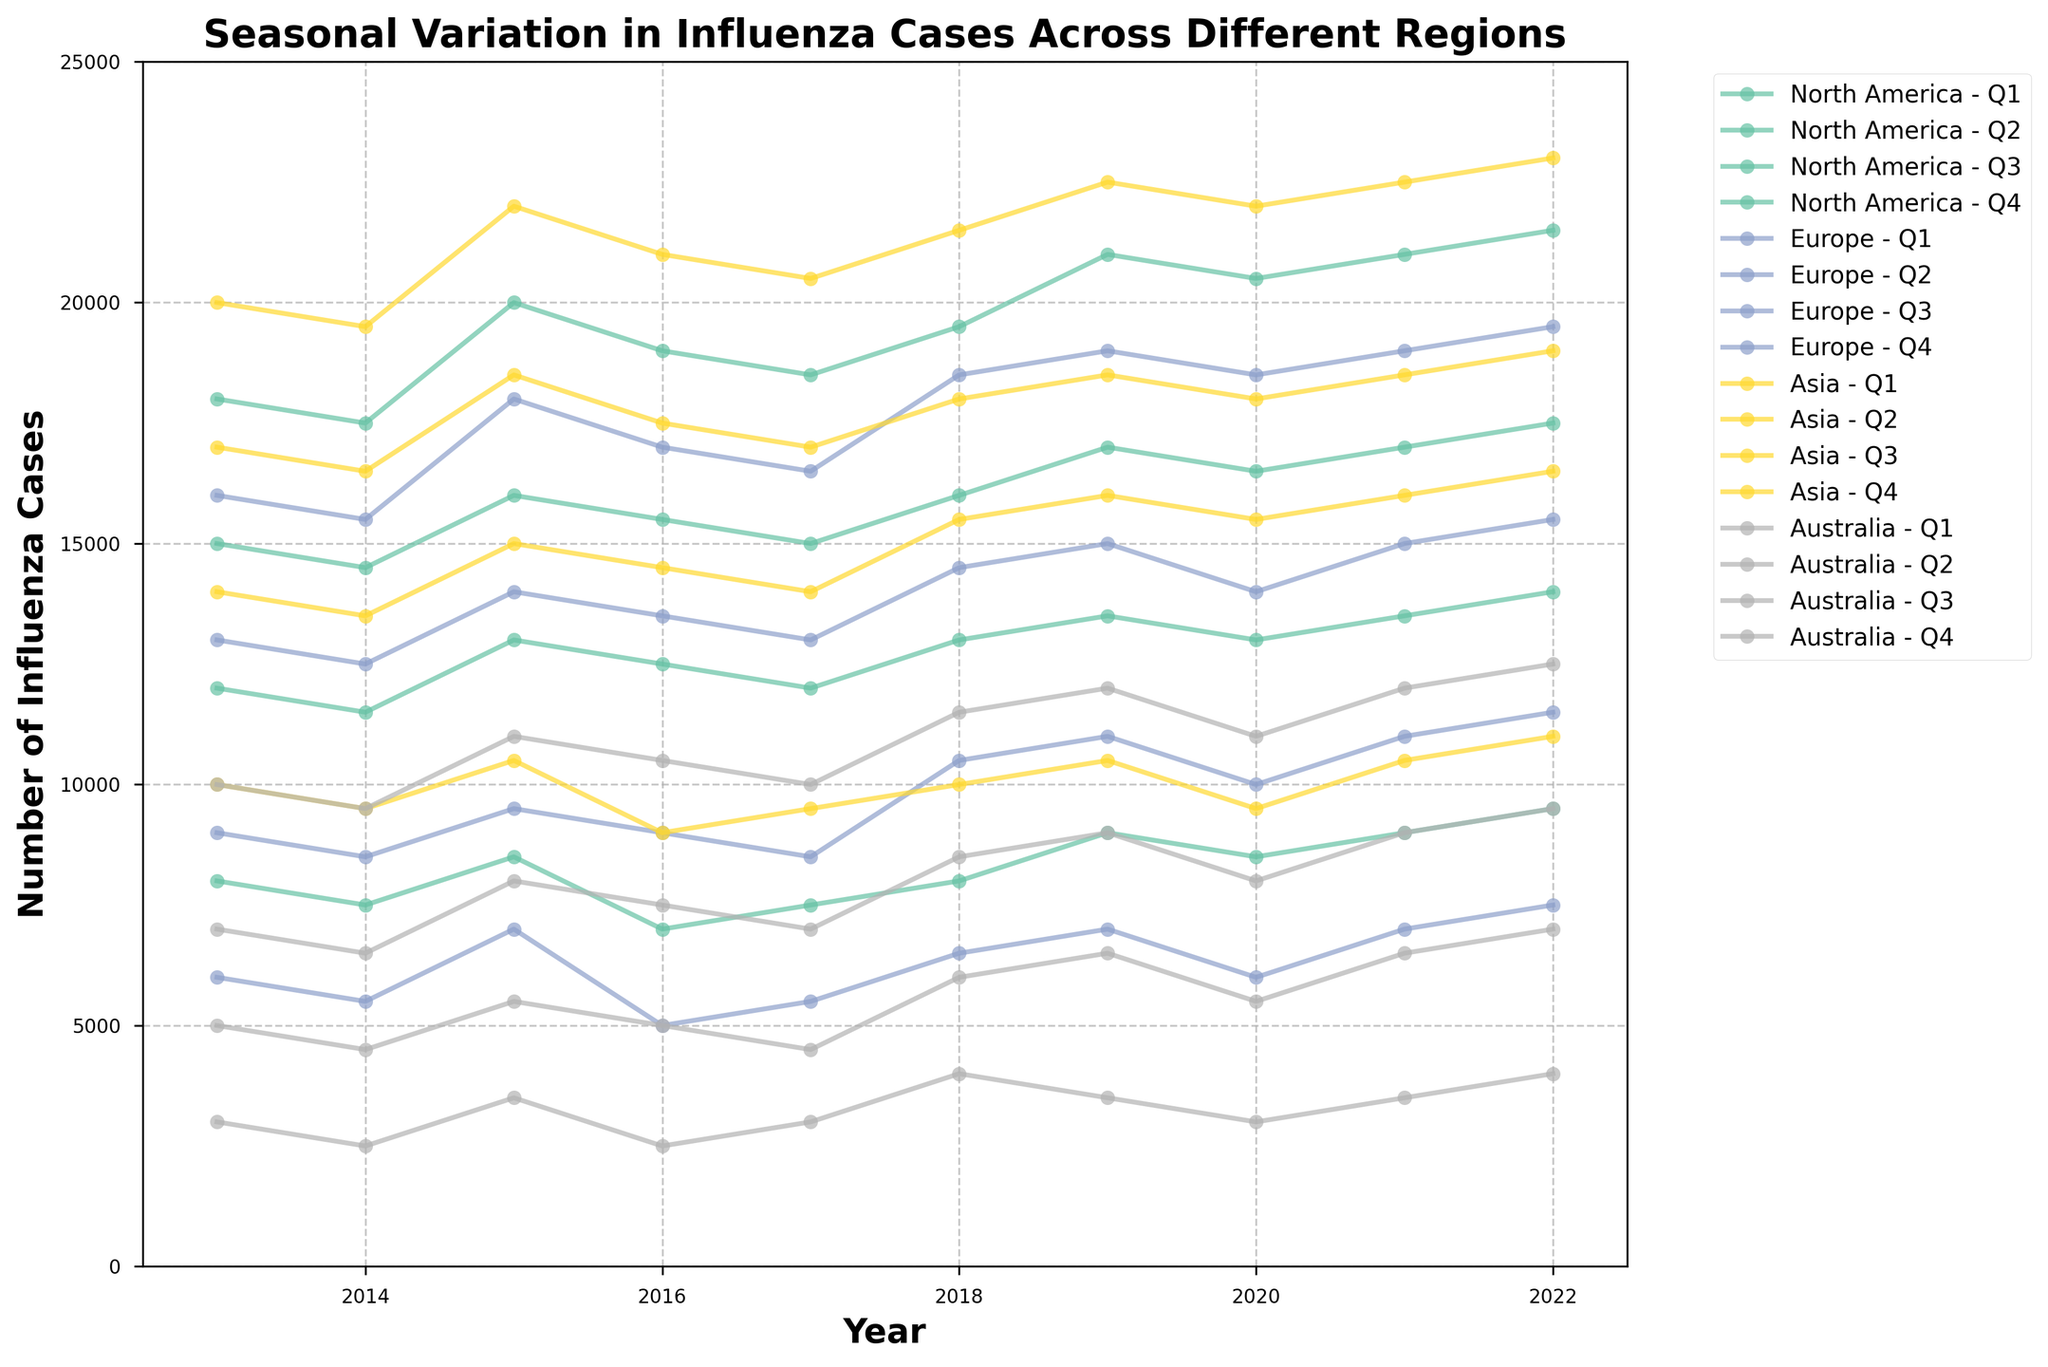Which region had the highest number of influenza cases in Q1 of 2022? Look at the line representing Q1 of 2022 for each region and identify the highest point.
Answer: Asia What is the title of the plot? Locate the title at the top of the plot.
Answer: Seasonal Variation in Influenza Cases Across Different Regions Comparing North America and Europe, which region had fewer cases in Q2 of 2015? Find the data points for North America and Europe in Q2 of 2015, then compare their values.
Answer: Europe How do the influenza cases in Australia during Q3 generally compare to Q1 over the years? Examine the trend of data points for Australia in Q1 and Q3 and compare the values visually.
Answer: Q3 usually has fewer cases than Q1 What trend can be observed in North America's influenza cases in Q4 from 2013 to 2022? Look at the data points for North America in Q4 across the years and describe the pattern.
Answer: Generally increasing Which quarter consistently showed the lowest number of cases in Europe? Compare the trends for Q1, Q2, Q3, and Q4 in Europe and identify the quarter with generally the lowest data points.
Answer: Q3 What is the difference in the number of influenza cases between Q1 and Q4 in Asia for the year 2018? Find the data points for Asia in Q1 and Q4 of 2018 and calculate the difference: 21500 (Q1) - 18000 (Q4).
Answer: 3500 Which region had the most significant drop in influenza cases from Q2 to Q3 in any year? Compare drops between Q2 and Q3 for each region and identify the largest drop.
Answer: Australia in 2013 Considering Q4 data points from 2013 to 2022, which region had the least variation in influenza cases? Visually assess the consistency of Q4 data points for each region and determine which has the least deviation.
Answer: North America Is there any region where influenza cases in Q2 remain relatively stable over the observed years? Compare the Q2 data points across the years for each region and identify if any exhibit a relatively stable trend.
Answer: Europe 